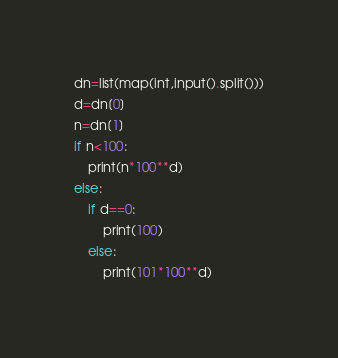<code> <loc_0><loc_0><loc_500><loc_500><_Python_>dn=list(map(int,input().split()))
d=dn[0]
n=dn[1]
if n<100:
    print(n*100**d)
else:
    if d==0:
        print(100)
    else:
        print(101*100**d)</code> 